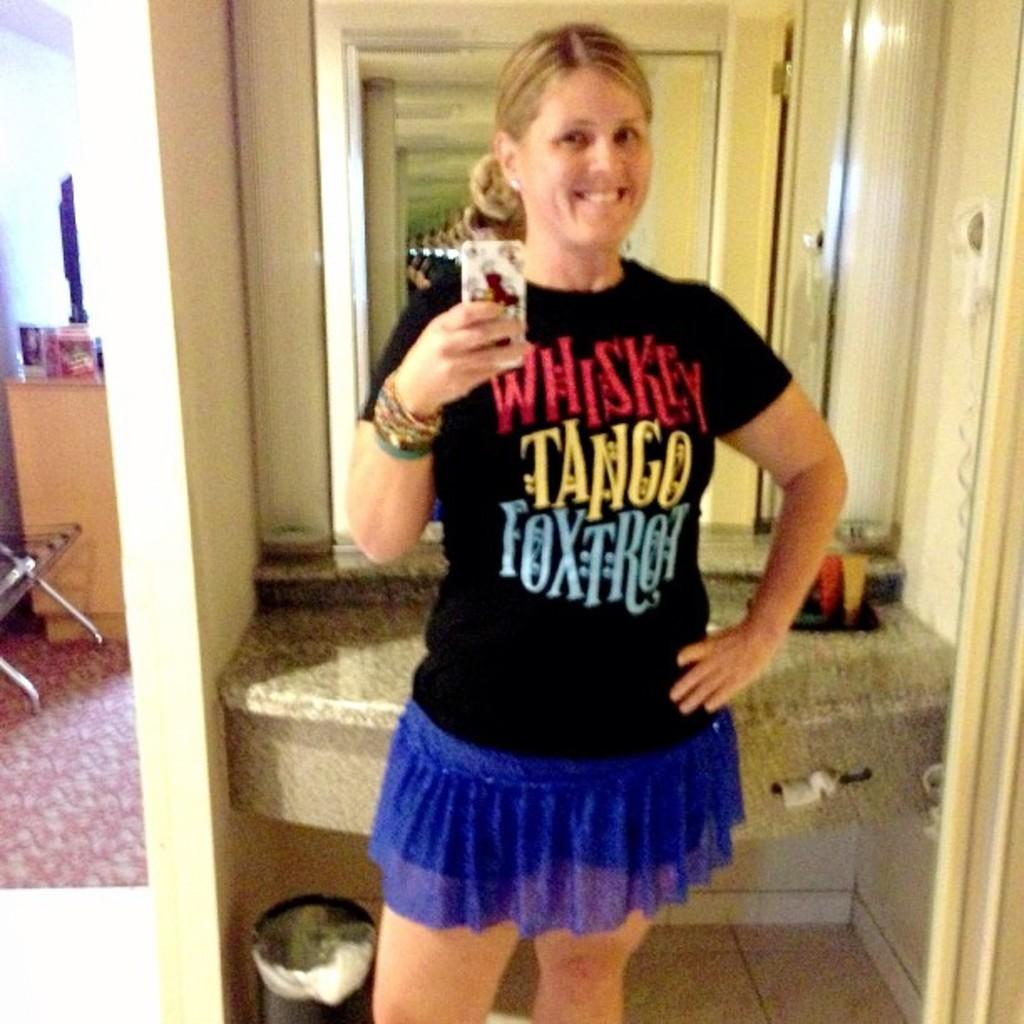Provide a one-sentence caption for the provided image. Lady holding cell phone with a black shirt that reads Whiskey Tango Foxtrot. 